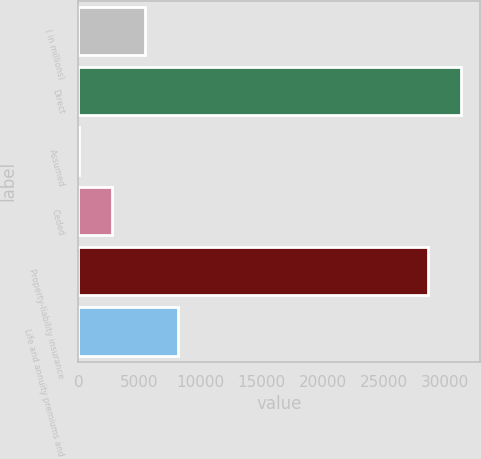<chart> <loc_0><loc_0><loc_500><loc_500><bar_chart><fcel>( in millions)<fcel>Direct<fcel>Assumed<fcel>Ceded<fcel>Property-liability insurance<fcel>Life and annuity premiums and<nl><fcel>5420<fcel>31298<fcel>29<fcel>2724.5<fcel>28602.5<fcel>8115.5<nl></chart> 